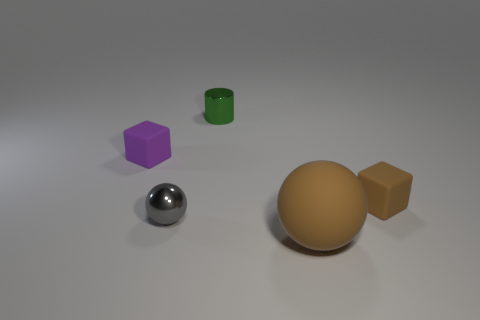Is there any other thing that has the same size as the cylinder?
Your answer should be very brief. Yes. There is a large object; is it the same color as the cube to the right of the tiny purple rubber thing?
Offer a very short reply. Yes. Are there any cubes that are on the left side of the cube that is in front of the purple object?
Provide a short and direct response. Yes. Is the number of small brown rubber objects that are right of the small brown matte block the same as the number of blocks in front of the tiny purple rubber thing?
Your response must be concise. No. What is the color of the tiny thing that is the same material as the gray ball?
Your response must be concise. Green. Are there any tiny cylinders made of the same material as the tiny gray thing?
Ensure brevity in your answer.  Yes. What number of things are purple rubber things or metallic cylinders?
Offer a very short reply. 2. Are the big ball and the small cube that is on the left side of the gray metal sphere made of the same material?
Make the answer very short. Yes. How big is the brown matte thing that is right of the large thing?
Your answer should be very brief. Small. Is the number of gray shiny balls less than the number of large blue metal cubes?
Give a very brief answer. No. 